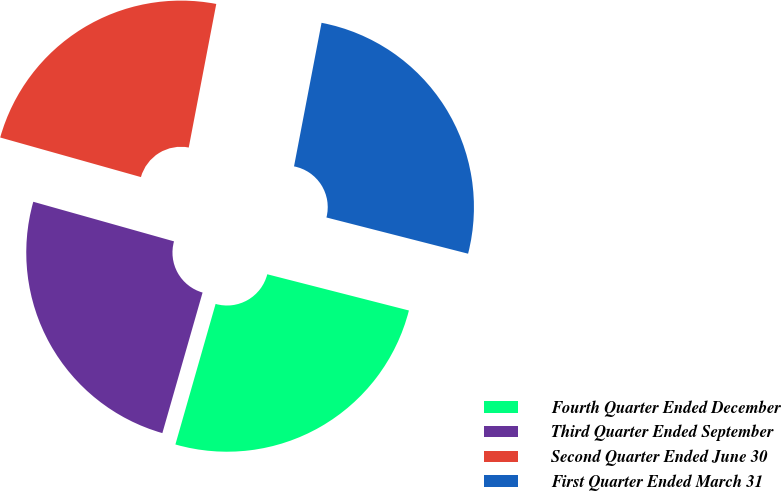<chart> <loc_0><loc_0><loc_500><loc_500><pie_chart><fcel>Fourth Quarter Ended December<fcel>Third Quarter Ended September<fcel>Second Quarter Ended June 30<fcel>First Quarter Ended March 31<nl><fcel>25.45%<fcel>24.93%<fcel>23.65%<fcel>25.97%<nl></chart> 